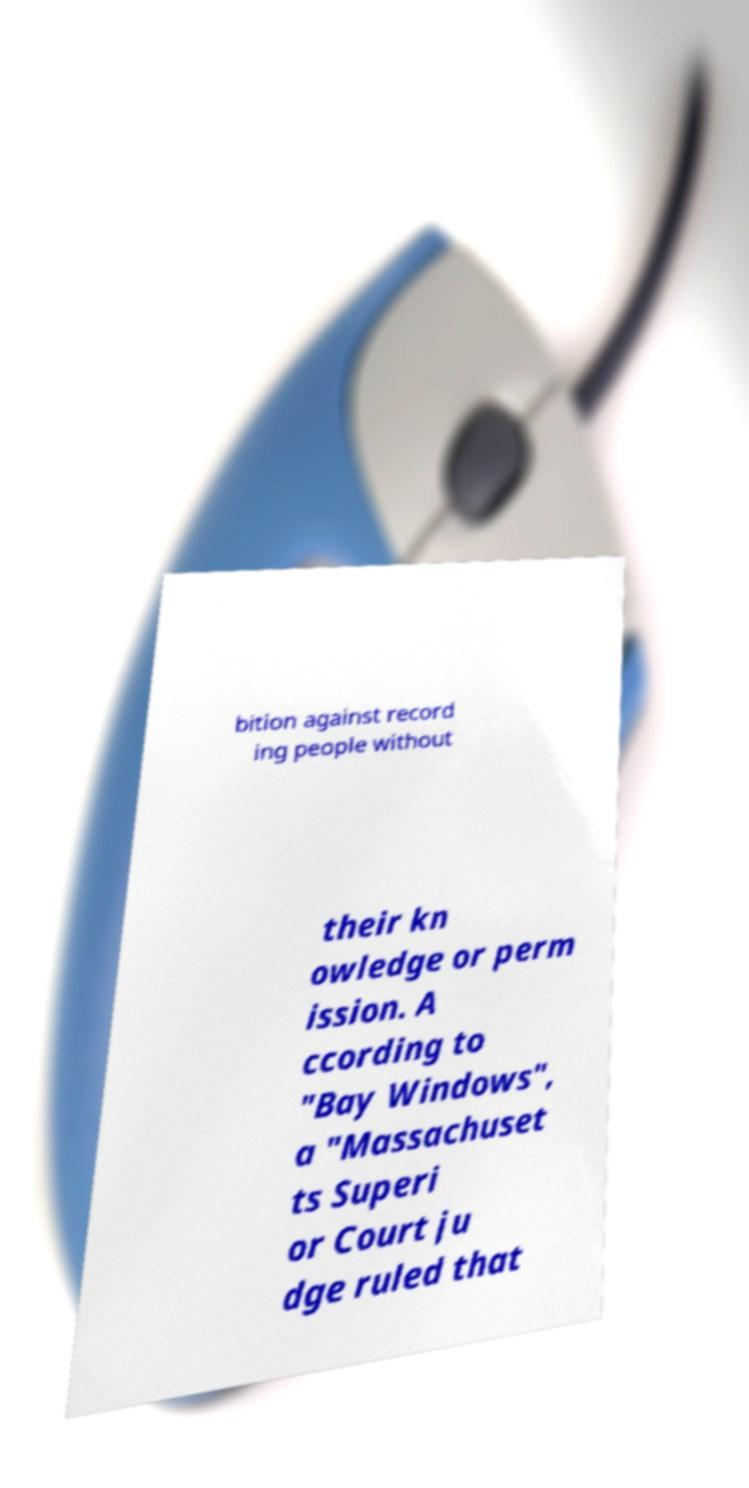Please read and relay the text visible in this image. What does it say? bition against record ing people without their kn owledge or perm ission. A ccording to "Bay Windows", a "Massachuset ts Superi or Court ju dge ruled that 